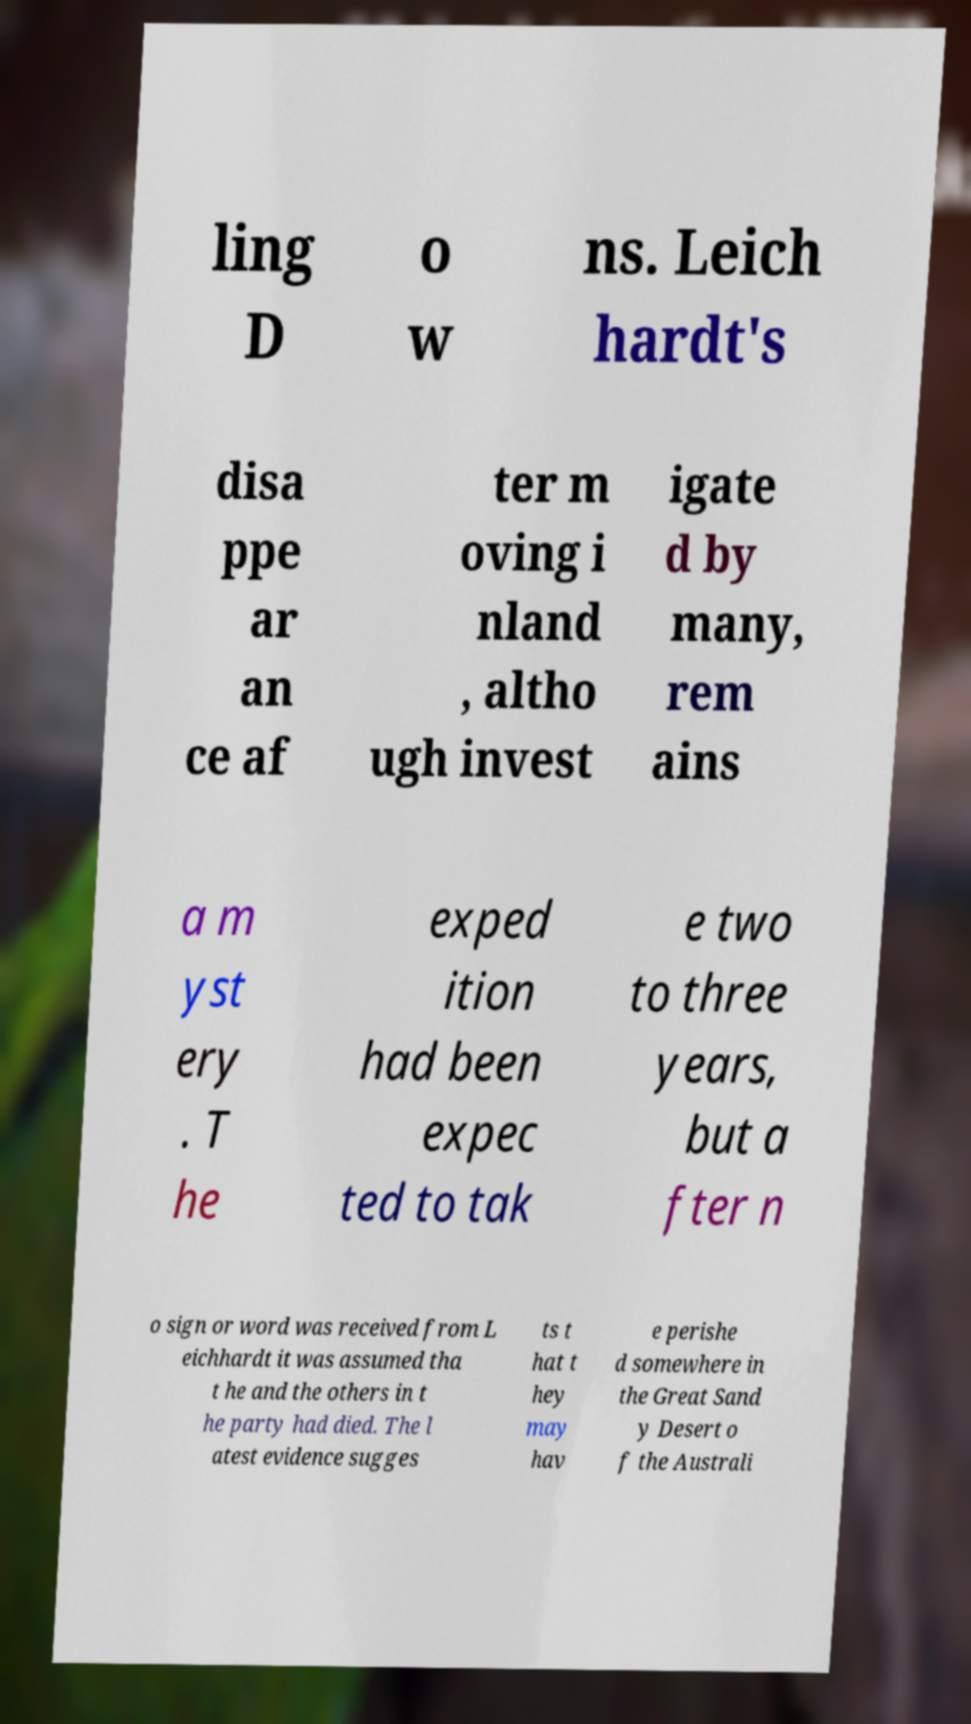I need the written content from this picture converted into text. Can you do that? ling D o w ns. Leich hardt's disa ppe ar an ce af ter m oving i nland , altho ugh invest igate d by many, rem ains a m yst ery . T he exped ition had been expec ted to tak e two to three years, but a fter n o sign or word was received from L eichhardt it was assumed tha t he and the others in t he party had died. The l atest evidence sugges ts t hat t hey may hav e perishe d somewhere in the Great Sand y Desert o f the Australi 